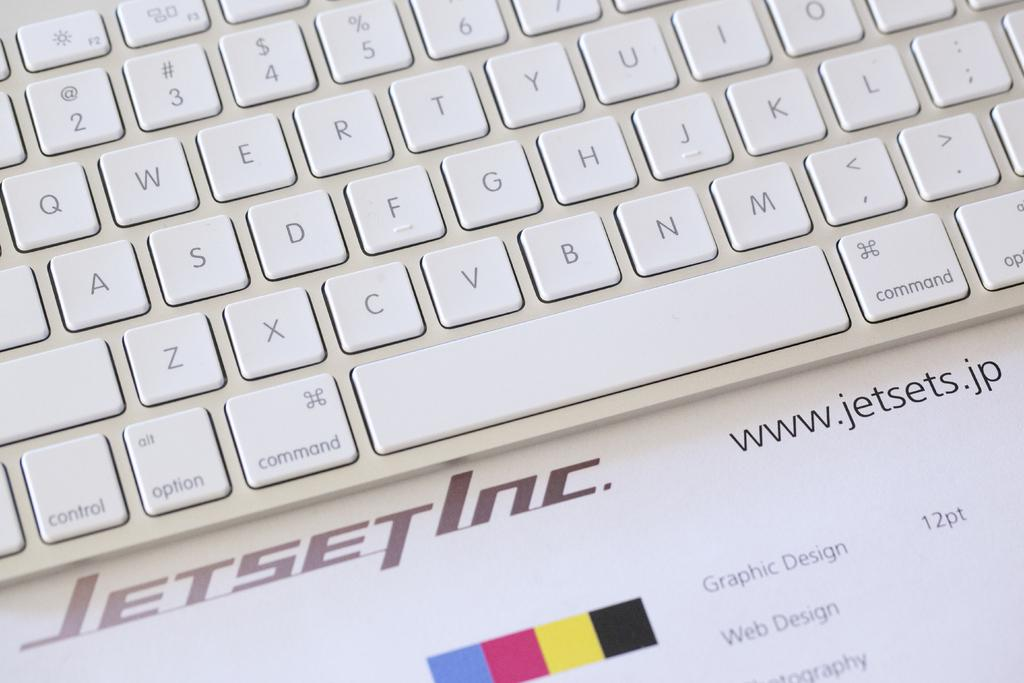<image>
Give a short and clear explanation of the subsequent image. White keyboard on top of a paper showing the website for jetsets. 